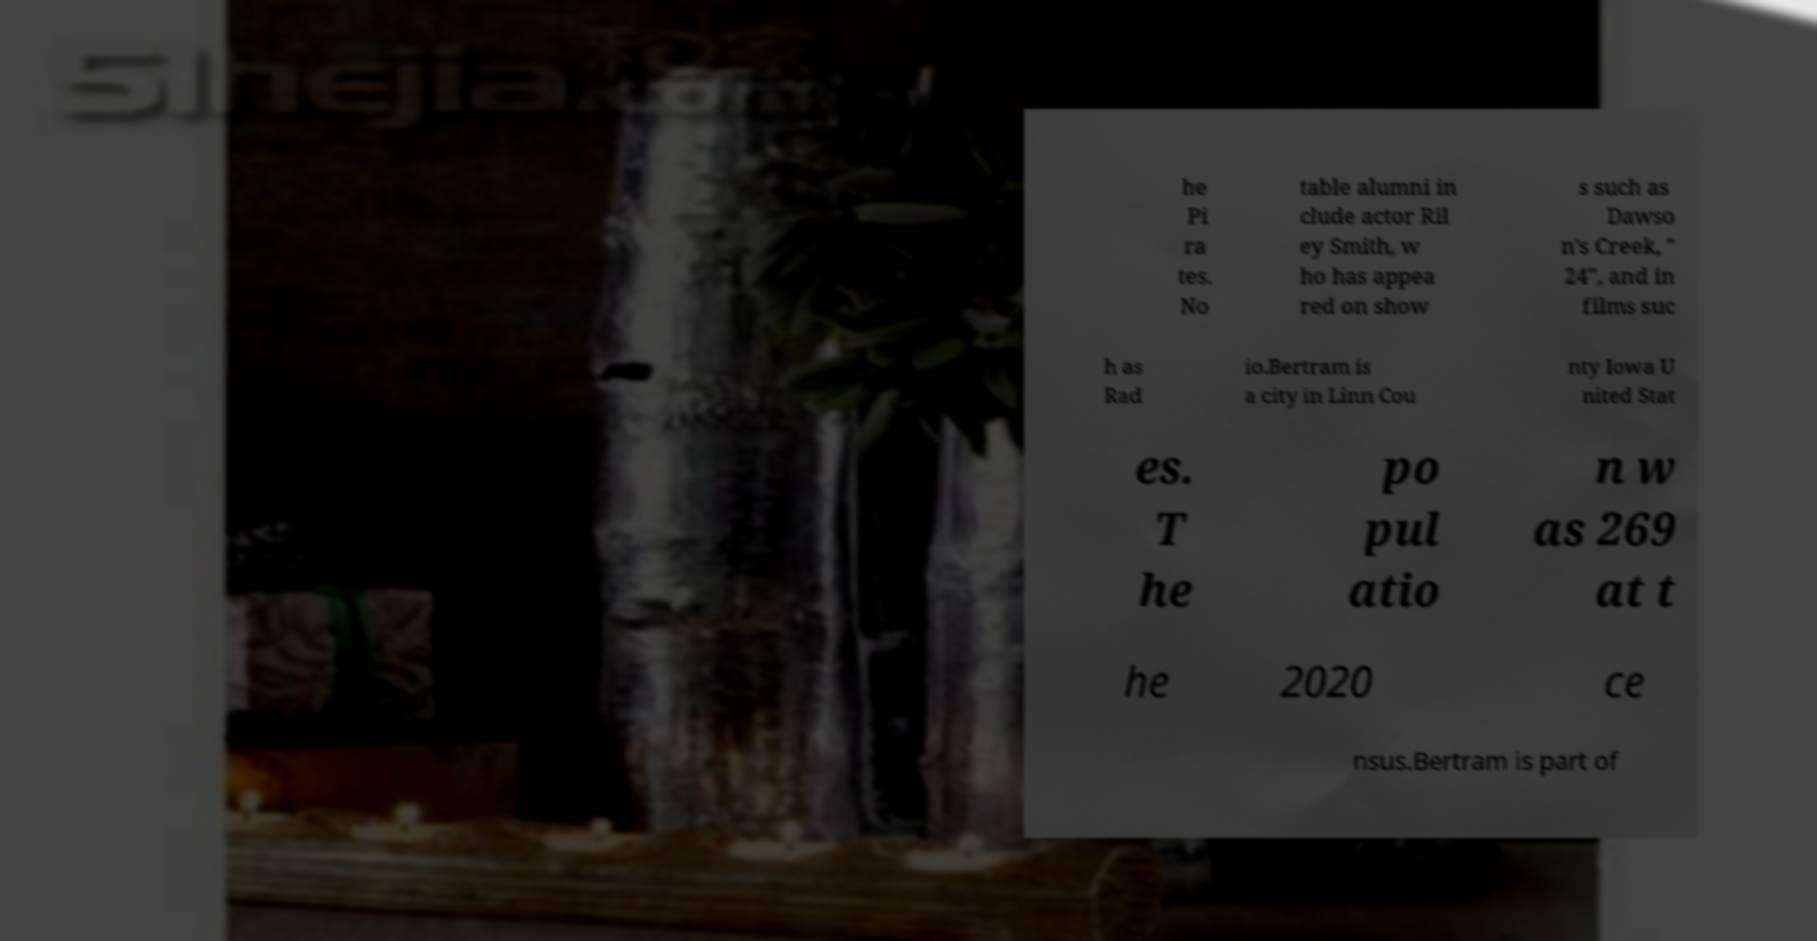Can you accurately transcribe the text from the provided image for me? he Pi ra tes. No table alumni in clude actor Ril ey Smith, w ho has appea red on show s such as Dawso n's Creek, " 24", and in films suc h as Rad io.Bertram is a city in Linn Cou nty Iowa U nited Stat es. T he po pul atio n w as 269 at t he 2020 ce nsus.Bertram is part of 